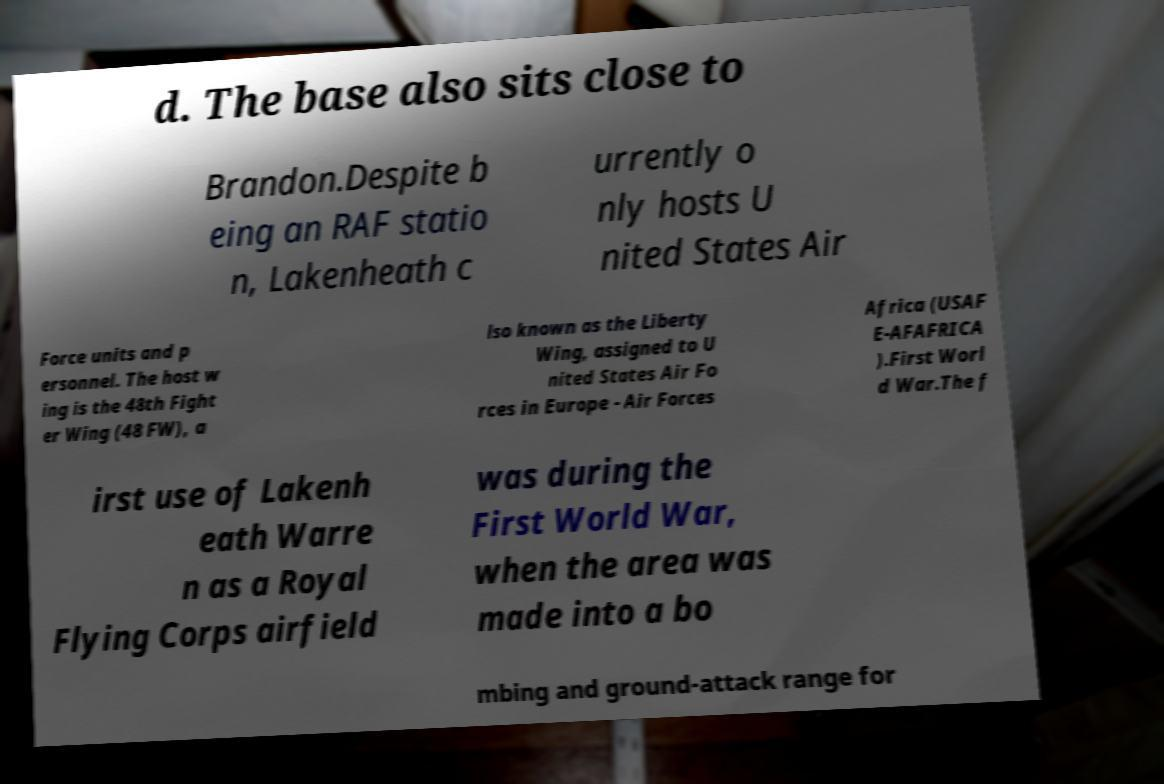I need the written content from this picture converted into text. Can you do that? d. The base also sits close to Brandon.Despite b eing an RAF statio n, Lakenheath c urrently o nly hosts U nited States Air Force units and p ersonnel. The host w ing is the 48th Fight er Wing (48 FW), a lso known as the Liberty Wing, assigned to U nited States Air Fo rces in Europe - Air Forces Africa (USAF E-AFAFRICA ).First Worl d War.The f irst use of Lakenh eath Warre n as a Royal Flying Corps airfield was during the First World War, when the area was made into a bo mbing and ground-attack range for 